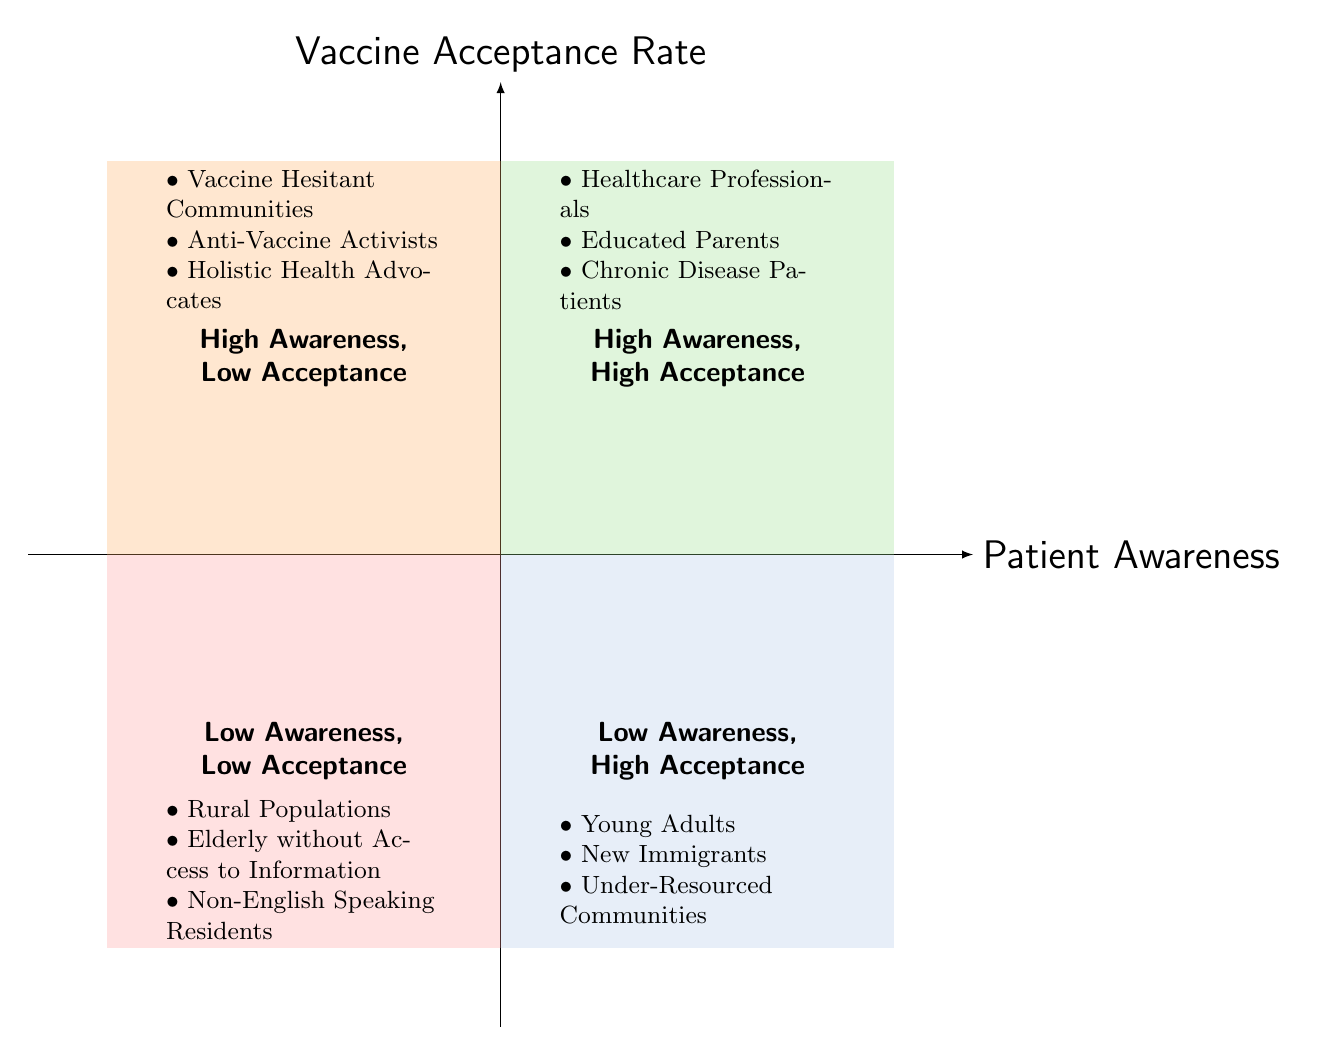What are the examples listed in the "High Awareness, High Acceptance" quadrant? The examples for this quadrant can be found by looking at the labels provided within the High Awareness, High Acceptance area of the diagram. The listed examples are: Healthcare Professionals, Educated Parents, and Chronic Disease Patients.
Answer: Healthcare Professionals, Educated Parents, Chronic Disease Patients Which quadrant contains "Vaccine Hesitant Communities"? To find the location of "Vaccine Hesitant Communities," we need to identify the quadrant that includes this example. It is listed under the High Awareness, Low Acceptance quadrant, meaning that's where it is positioned in the diagram.
Answer: High Awareness, Low Acceptance How many examples are there in the "Low Awareness, Low Acceptance" quadrant? By checking the number of listed examples in the Low Awareness, Low Acceptance quadrant, we find the examples are: Rural Populations, Elderly without Access to Information, and Non-English Speaking Residents. This gives us a total of three examples.
Answer: 3 What is the relationship between "Patient Awareness" and "Vaccine Acceptance Rate" in the "Low Awareness, High Acceptance" quadrant? To understand the relationship, we look at the designation of the quadrant which represents Low Awareness on the x-axis and High Acceptance on the y-axis. This indicates a scenario where patients are not fully aware of vaccines but still exhibit a willingness to accept them.
Answer: Low Awareness, High Acceptance Name one group from the "High Awareness, Low Acceptance" quadrant. To answer this, we check the examples listed in the High Awareness, Low Acceptance quadrant. One of the examples is "Anti-Vaccine Activists."
Answer: Anti-Vaccine Activists How does "Young Adults" fit into the quadrants? "Young Adults" is mentioned as an example in the Low Awareness, High Acceptance quadrant. This means they generally have low awareness regarding vaccines but display a high acceptance rate when recommended or educated.
Answer: Low Awareness, High Acceptance In which quadrant do "Chronic Disease Patients" fall? We identify the placement of "Chronic Disease Patients" in the diagram. They are part of the High Awareness, High Acceptance quadrant, implying they are both informed and willing to receive vaccines.
Answer: High Awareness, High Acceptance Which quadrants indicate a population with both low awareness and low acceptance? To find the quadrants that match this description, we look for the quadrant with both factors being low, which is explicitly labeled as Low Awareness, Low Acceptance. This is the only quadrant reflecting this situation.
Answer: Low Awareness, Low Acceptance 